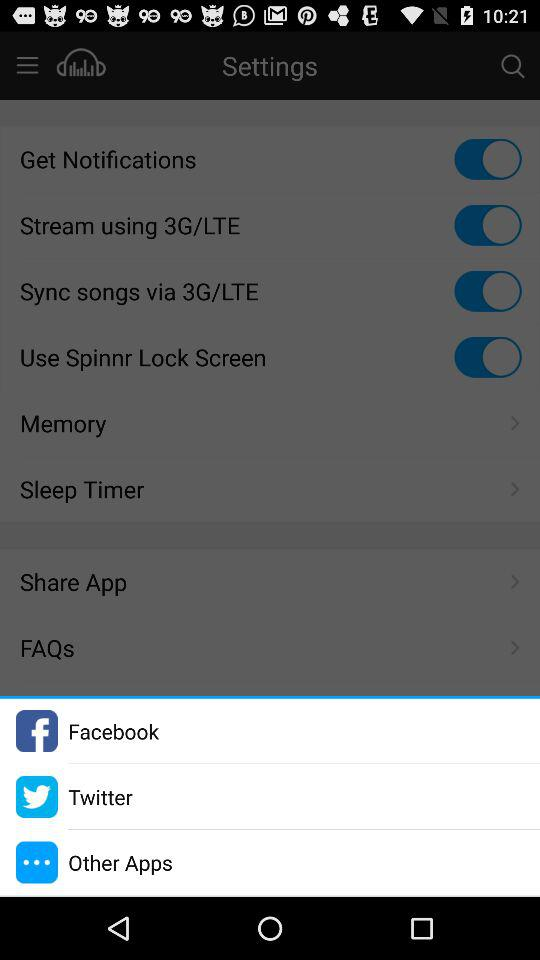Which are the different mentioned applications? The different mentioned applications are "Facebook" and "Twitter". 